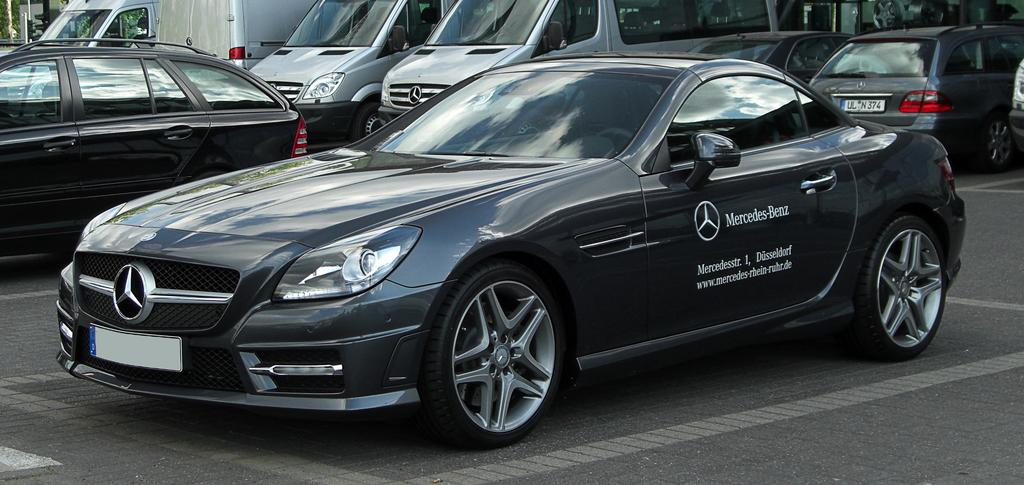What type of vehicles can be seen in the image? There are cars in the image. What else is present in the image besides the cars? There are words written in the image, a logo, number plates on the cars, and a path with white lines. Can you describe the logo in the image? Unfortunately, the facts provided do not give a description of the logo. What might the white lines on the path indicate? The white lines on the path could indicate a designated area for traffic or pedestrians. How many mice are running along the white lines on the path in the image? There are no mice present in the image; it features cars, words, a logo, number plates, and a path with white lines. 